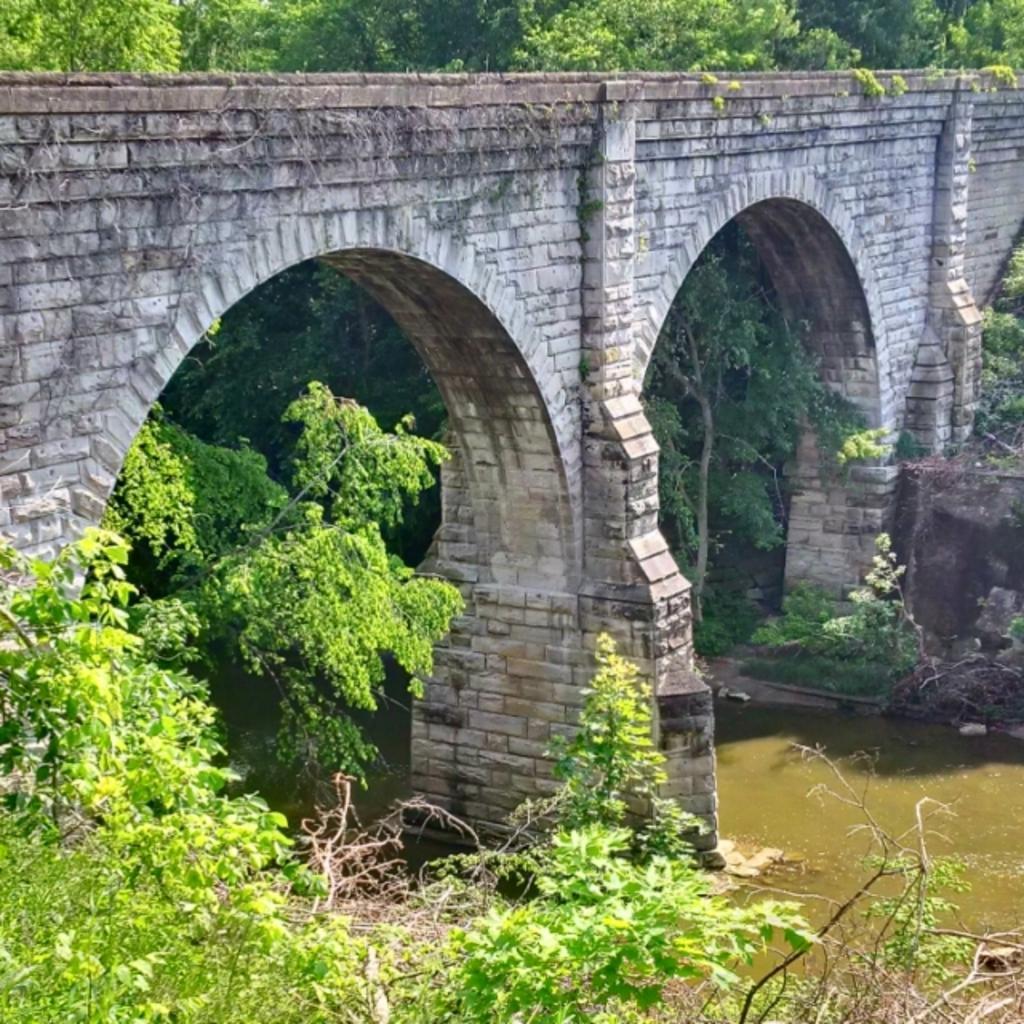Could you give a brief overview of what you see in this image? In this image at the bottom we can see the plants and in the middle we can see a bridge and on the right side we can see the water and in the background we can see some trees. 